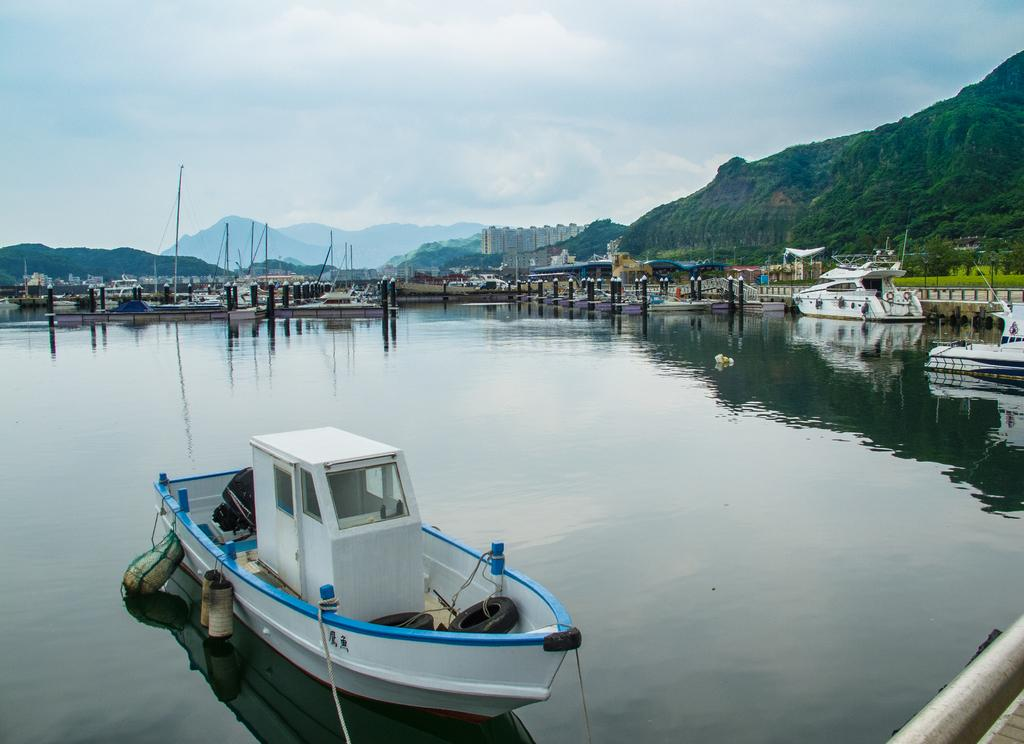What is in the water in the image? There are ships in the water in the image. What structures can be seen in the image? There are poles, trees, buildings, and mountains in the image. What is visible in the sky at the top of the image? There are clouds in the sky at the top of the image. Where is the volleyball court located in the image? There is no volleyball court present in the image. What type of nail is being used to hold the buildings together in the image? There is no mention of nails being used to hold the buildings together in the image. 